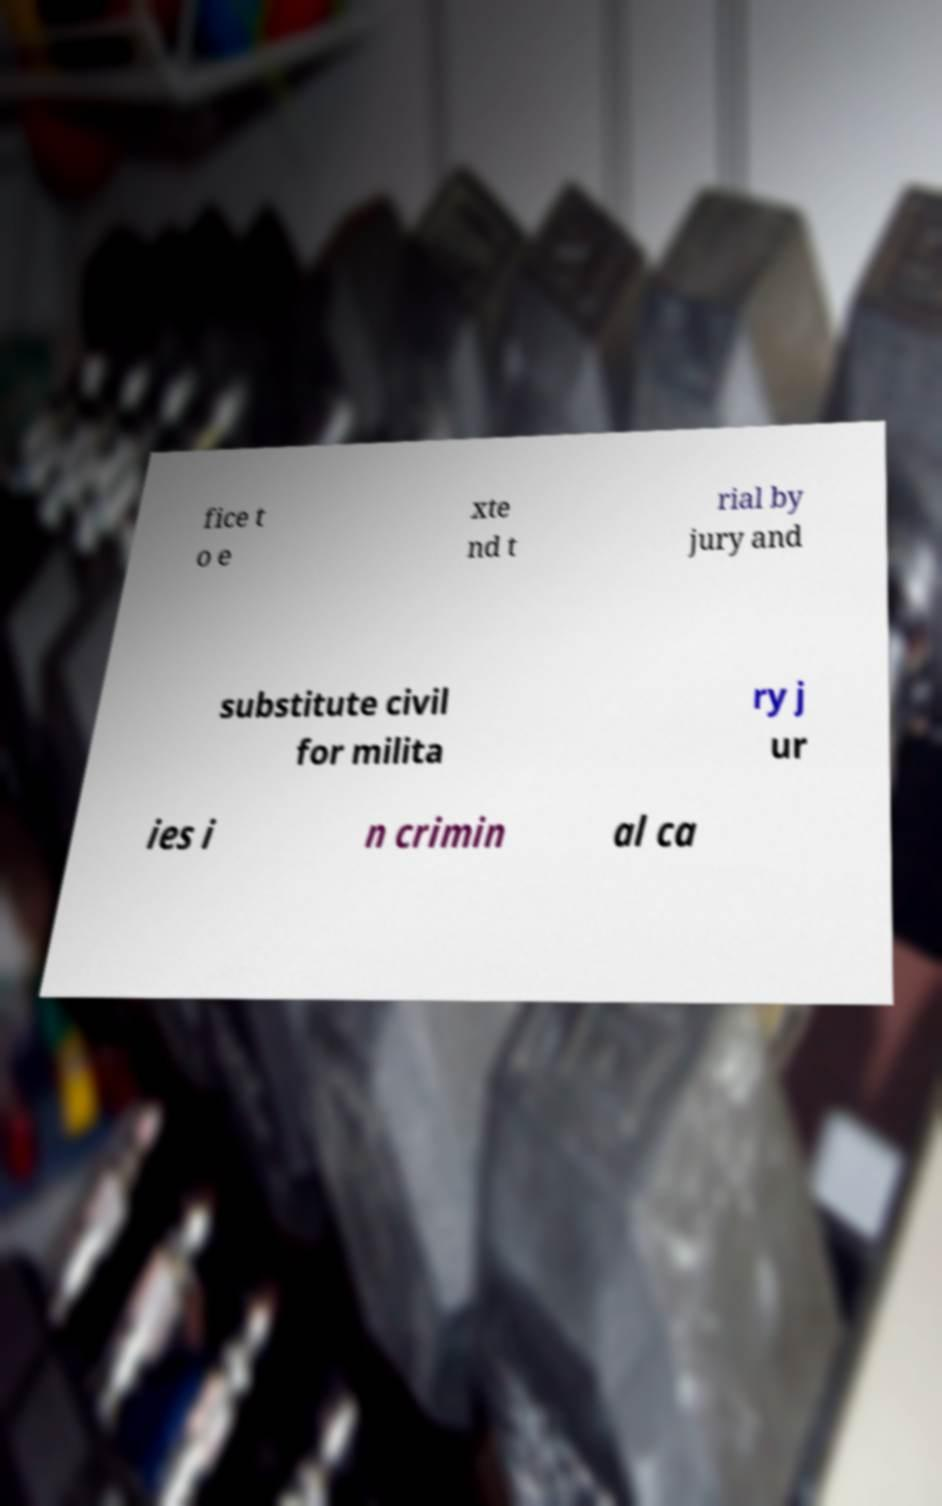Please read and relay the text visible in this image. What does it say? fice t o e xte nd t rial by jury and substitute civil for milita ry j ur ies i n crimin al ca 